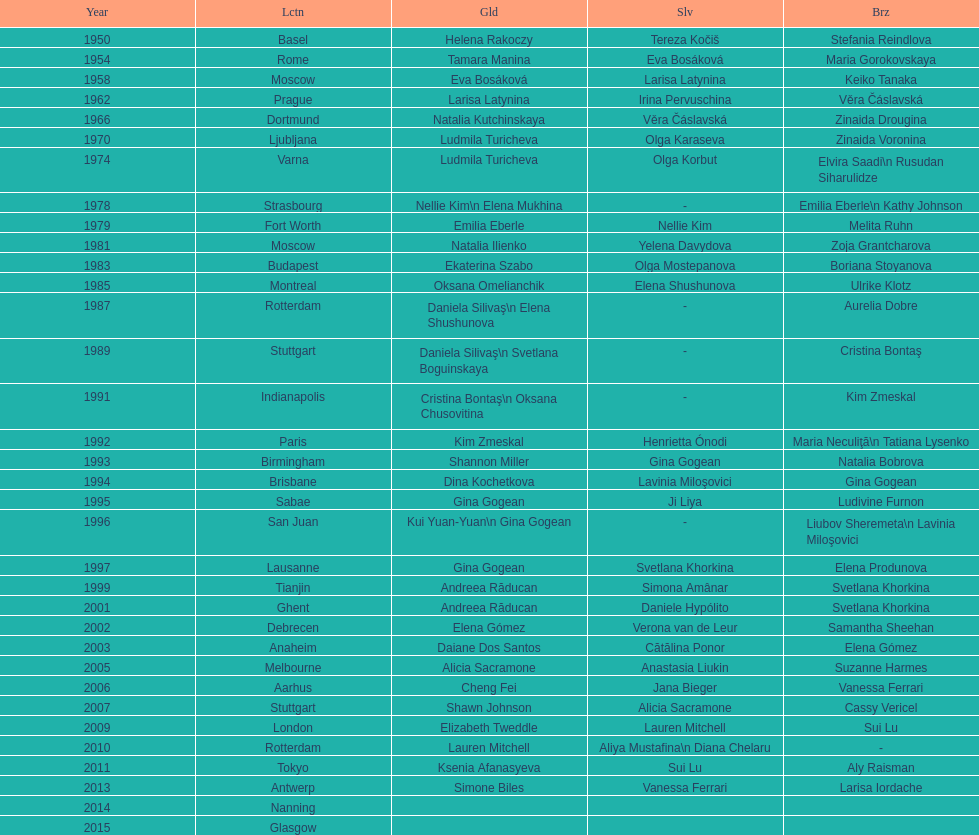How many times was the world artistic gymnastics championships held in the united states? 3. 